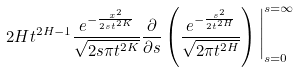<formula> <loc_0><loc_0><loc_500><loc_500>2 H t ^ { 2 H - 1 } \frac { e ^ { - \frac { x ^ { 2 } } { 2 s t ^ { 2 K } } } } { \sqrt { 2 s \pi t ^ { 2 K } } } \frac { \partial } { \partial s } \left ( \frac { e ^ { - \frac { s ^ { 2 } } { 2 t ^ { 2 H } } } } { \sqrt { 2 \pi t ^ { 2 H } } } \right ) \Big | _ { s = 0 } ^ { s = \infty }</formula> 